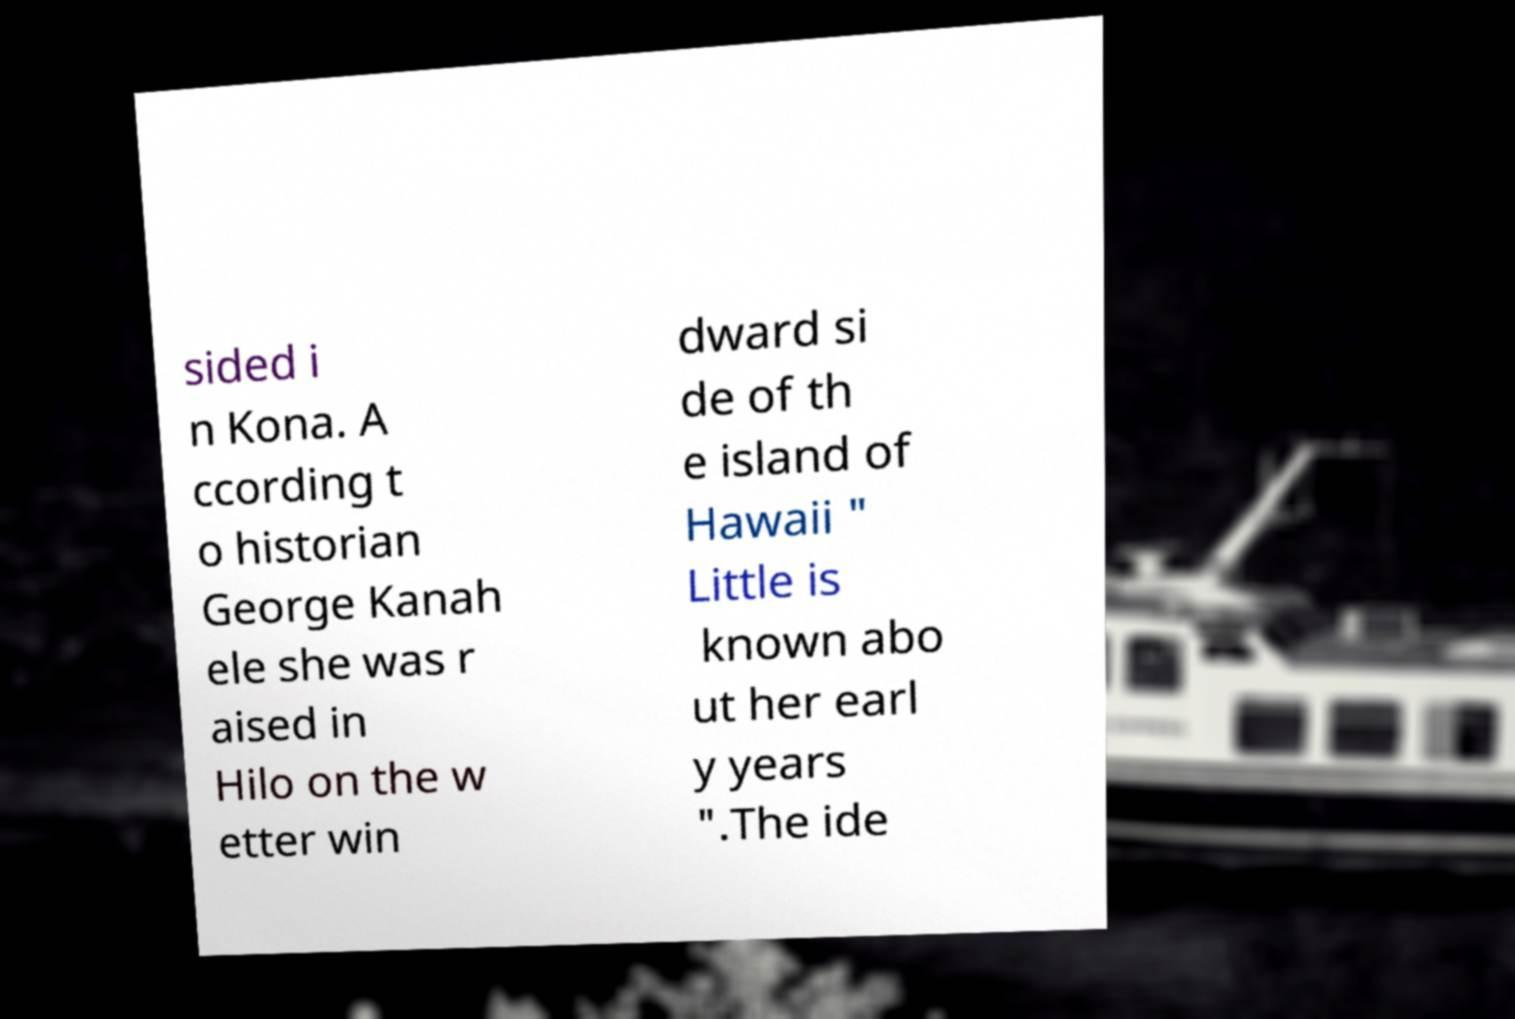Can you accurately transcribe the text from the provided image for me? sided i n Kona. A ccording t o historian George Kanah ele she was r aised in Hilo on the w etter win dward si de of th e island of Hawaii " Little is known abo ut her earl y years ".The ide 